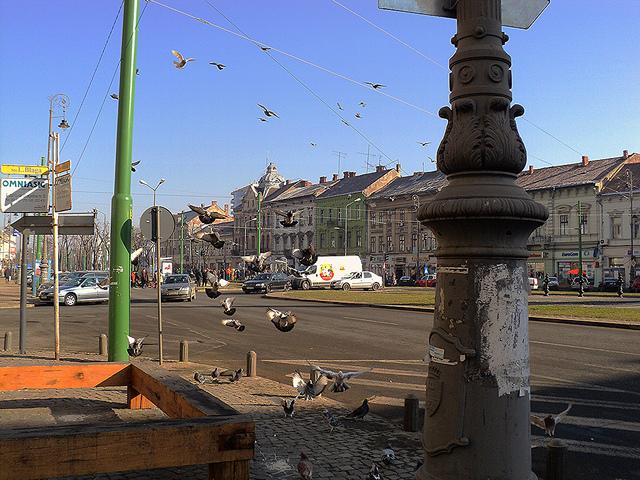Is it night time?
Quick response, please. No. What type of birds are these?
Keep it brief. Pigeons. Is this a highly populated area?
Keep it brief. Yes. 